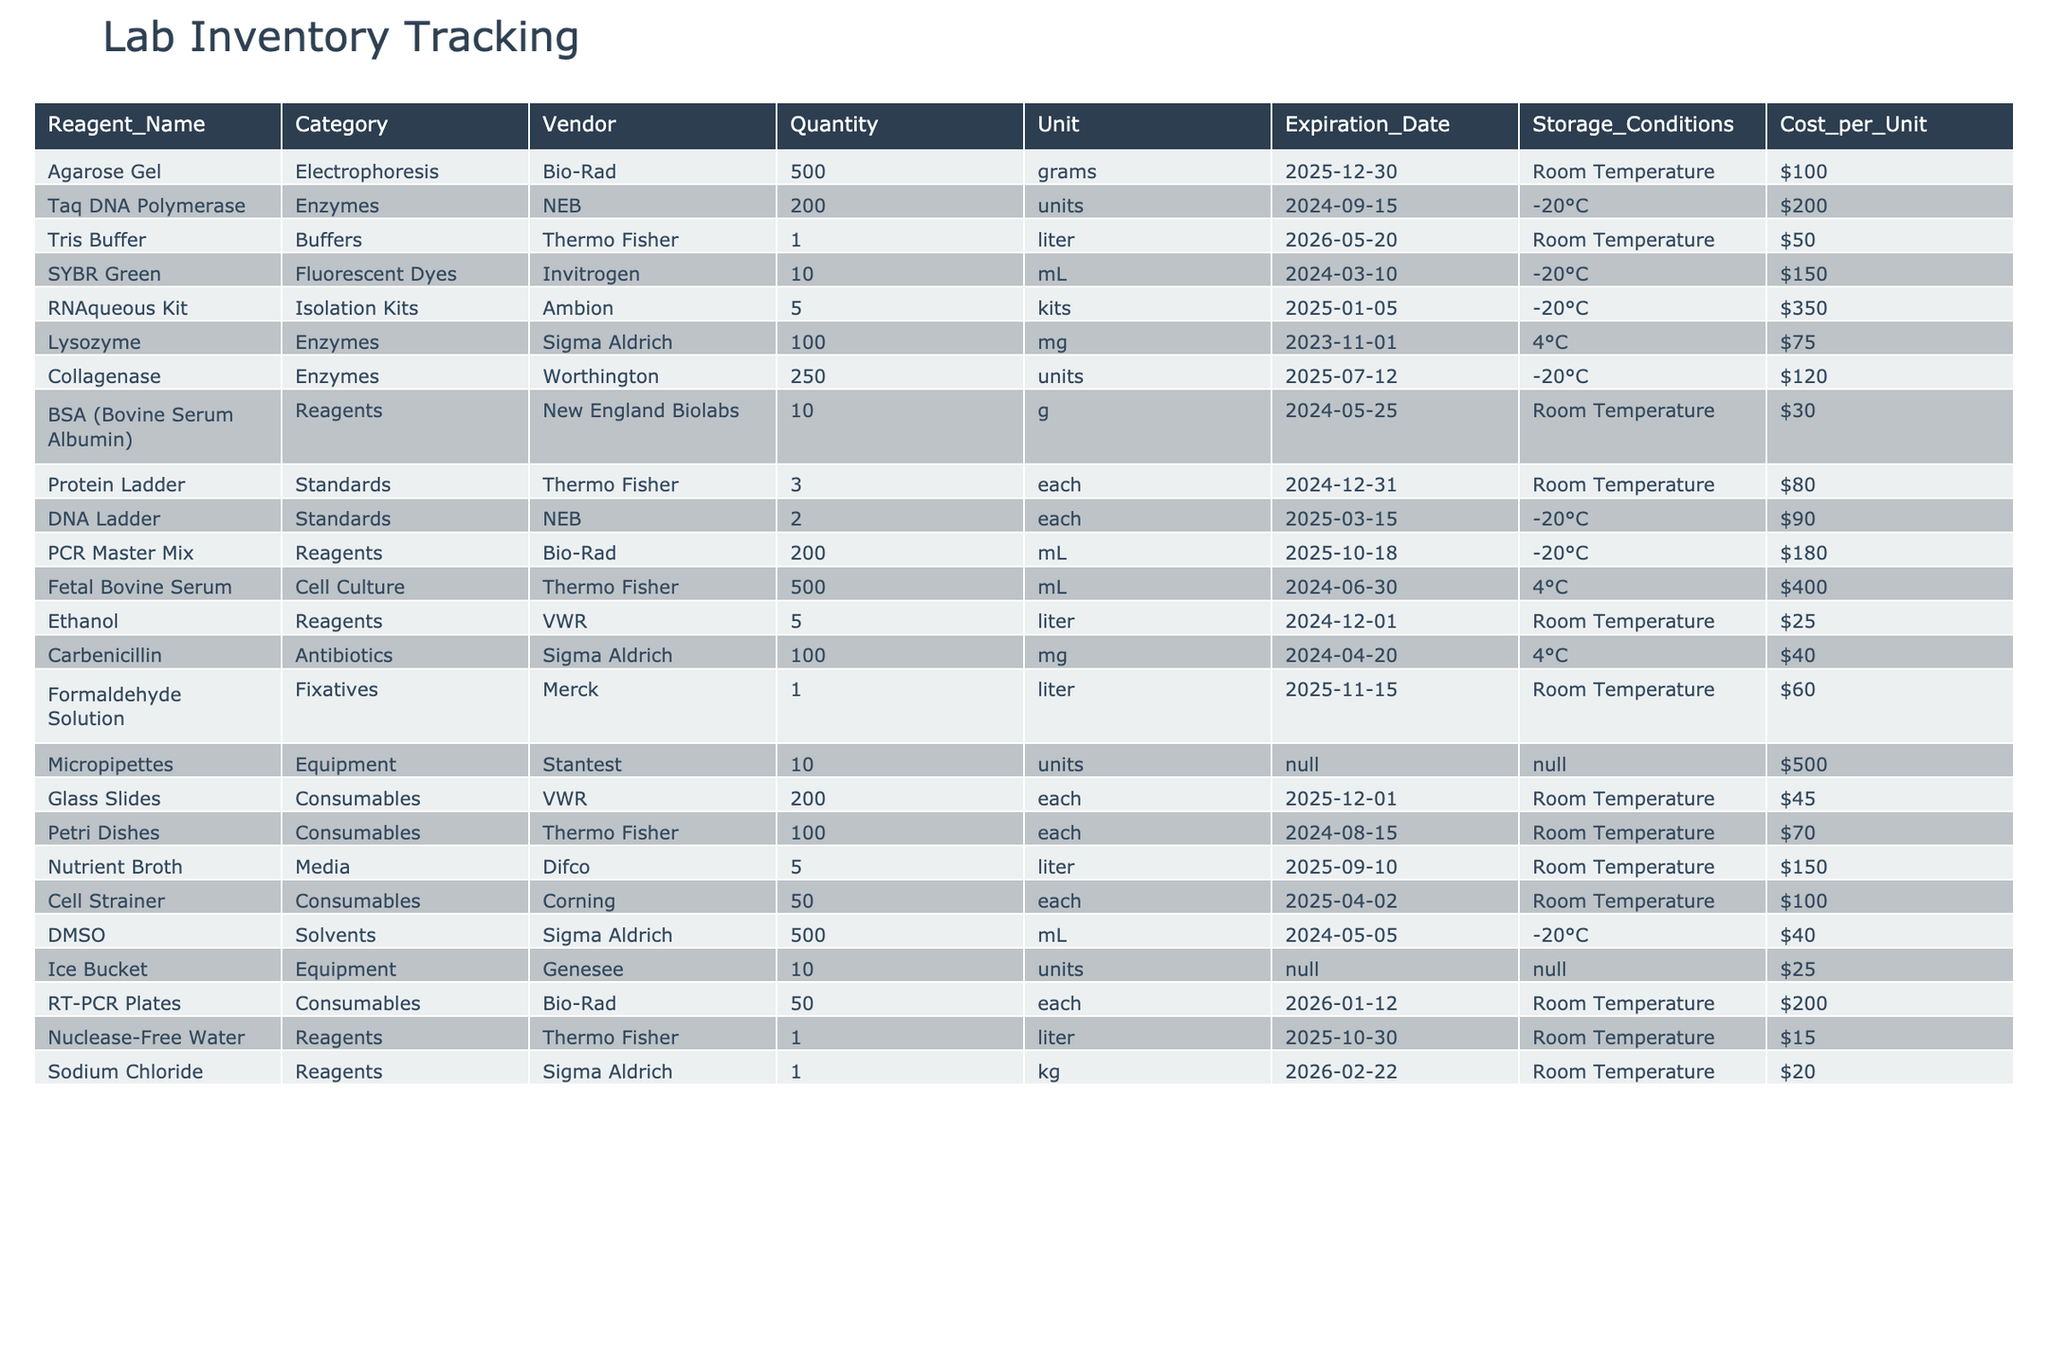What is the expiration date of Taq DNA Polymerase? The expiration date for Taq DNA Polymerase is listed as September 15, 2024, which can be found in the corresponding row of the table.
Answer: September 15, 2024 How many units of Collagenase are available? According to the table, the available quantity of Collagenase is 250 units, as indicated in the relevant column.
Answer: 250 units What is the total cost of all reagents that need to be stored at -20°C? We find the costs of Taq DNA Polymerase ($200), SYBR Green ($150), RNAqueous Kit ($350), Collagenase ($120), PCR Master Mix ($180), DNA Ladder ($90), and DMSO ($40). Adding these amounts gives us $200 + $150 + $350 + $120 + $180 + $90 + $40 = $1,230.
Answer: $1,230 Is there any reagent that has an expiration date next month? By examining the expiration dates, Lysozyme expires on November 1, 2023. Thus, there is indeed a reagent expiring next month.
Answer: Yes What is the total quantity of consumables in the inventory? The table lists Glass Slides (200 each), Petri Dishes (100 each), Cell Strainer (50 each), and RT-PCR Plates (50 each). Summing them gives us 200 + 100 + 50 + 50 = 400.
Answer: 400 Which vendor supplies the most reagents? By counting the occurrences in the Vendor column, Thermo Fisher appears four times, which is more than any other vendor in the table.
Answer: Thermo Fisher How much does a liter of Tris Buffer cost? The cost for Tris Buffer is $50, as specified in the table.
Answer: $50 What is the average cost of reagents stored at Room Temperature? The relevant reagents are Agarose Gel ($100), BSA ($30), Ethanol ($25), Formaldehyde Solution ($60), Glass Slides ($45), Petri Dishes ($70), Nutrient Broth ($150), Nuclease-Free Water ($15), and Sodium Chloride ($20). The total cost sums to $100 + $30 + $25 + $60 + $45 + $70 + $150 + $15 + $20 = $515. There are 9 reagents, so the average is $515 / 9 = $57.22.
Answer: $57.22 How many different categories of reagents and supplies are listed? The categories are: Electrophoresis, Enzymes, Buffers, Fluorescent Dyes, Isolation Kits, Reagents, Standards, Cell Culture, Antibiotics, Fixatives, Equipment, Consumables, Media, and Solvents. Counting these gives us a total of 14 unique categories.
Answer: 14 What is the storage condition for the Fetal Bovine Serum? The storage condition for Fetal Bovine Serum is specified as 4°C in the table.
Answer: 4°C 